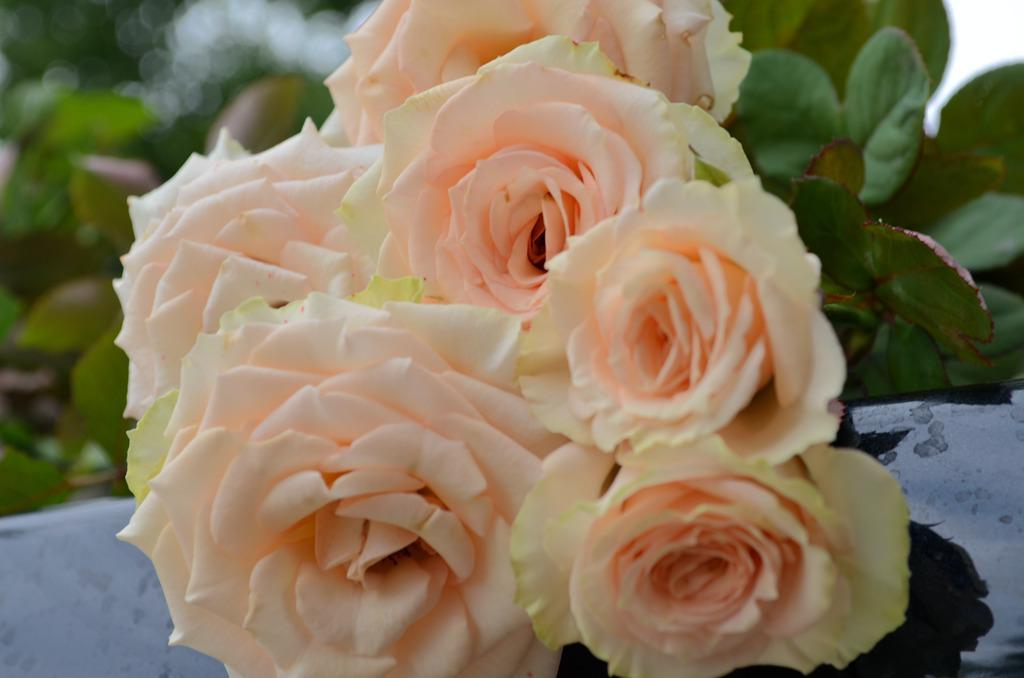What type of plants can be seen in the image? There are flowering plants in the image. Can you determine the time of day when the image was taken? The image is likely taken during the day, as there is sufficient light to see the flowering plants. How many times does the truck sneeze in the image? There is no truck present in the image, so it cannot sneeze. 